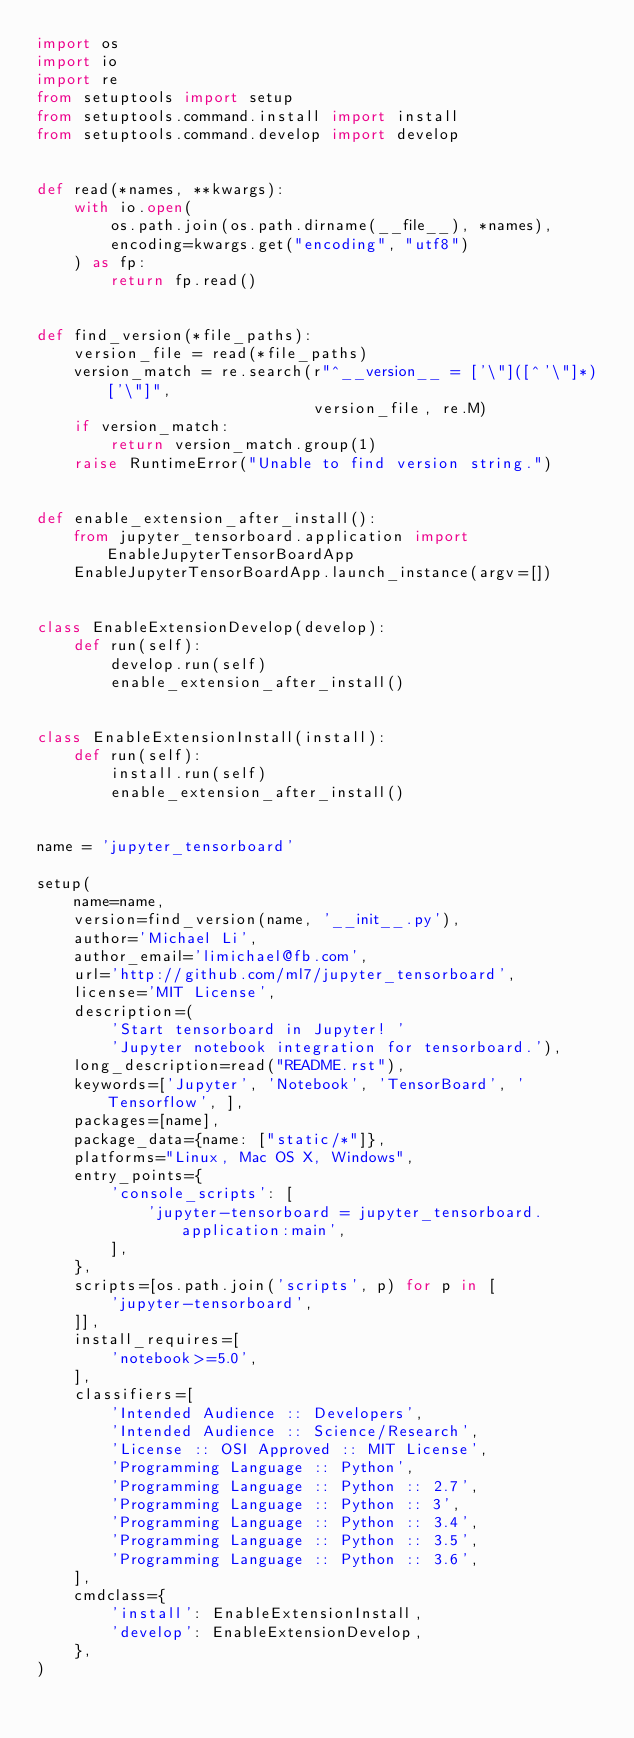<code> <loc_0><loc_0><loc_500><loc_500><_Python_>import os
import io
import re
from setuptools import setup
from setuptools.command.install import install
from setuptools.command.develop import develop


def read(*names, **kwargs):
    with io.open(
        os.path.join(os.path.dirname(__file__), *names),
        encoding=kwargs.get("encoding", "utf8")
    ) as fp:
        return fp.read()


def find_version(*file_paths):
    version_file = read(*file_paths)
    version_match = re.search(r"^__version__ = ['\"]([^'\"]*)['\"]",
                              version_file, re.M)
    if version_match:
        return version_match.group(1)
    raise RuntimeError("Unable to find version string.")


def enable_extension_after_install():
    from jupyter_tensorboard.application import EnableJupyterTensorBoardApp
    EnableJupyterTensorBoardApp.launch_instance(argv=[])


class EnableExtensionDevelop(develop):
    def run(self):
        develop.run(self)
        enable_extension_after_install()


class EnableExtensionInstall(install):
    def run(self):
        install.run(self)
        enable_extension_after_install()


name = 'jupyter_tensorboard'

setup(
    name=name,
    version=find_version(name, '__init__.py'),
    author='Michael Li',
    author_email='limichael@fb.com',
    url='http://github.com/ml7/jupyter_tensorboard',
    license='MIT License',
    description=(
        'Start tensorboard in Jupyter! '
        'Jupyter notebook integration for tensorboard.'),
    long_description=read("README.rst"),
    keywords=['Jupyter', 'Notebook', 'TensorBoard', 'Tensorflow', ],
    packages=[name],
    package_data={name: ["static/*"]},
    platforms="Linux, Mac OS X, Windows",
    entry_points={
        'console_scripts': [
            'jupyter-tensorboard = jupyter_tensorboard.application:main',
        ],
    },
    scripts=[os.path.join('scripts', p) for p in [
        'jupyter-tensorboard',
    ]],
    install_requires=[
        'notebook>=5.0',
    ],
    classifiers=[
        'Intended Audience :: Developers',
        'Intended Audience :: Science/Research',
        'License :: OSI Approved :: MIT License',
        'Programming Language :: Python',
        'Programming Language :: Python :: 2.7',
        'Programming Language :: Python :: 3',
        'Programming Language :: Python :: 3.4',
        'Programming Language :: Python :: 3.5',
        'Programming Language :: Python :: 3.6',
    ],
    cmdclass={
        'install': EnableExtensionInstall,
        'develop': EnableExtensionDevelop,
    },
)
</code> 